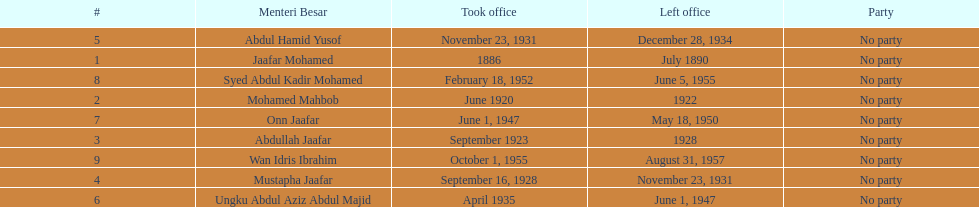Who were all of the menteri besars? Jaafar Mohamed, Mohamed Mahbob, Abdullah Jaafar, Mustapha Jaafar, Abdul Hamid Yusof, Ungku Abdul Aziz Abdul Majid, Onn Jaafar, Syed Abdul Kadir Mohamed, Wan Idris Ibrahim. When did they take office? 1886, June 1920, September 1923, September 16, 1928, November 23, 1931, April 1935, June 1, 1947, February 18, 1952, October 1, 1955. And when did they leave? July 1890, 1922, 1928, November 23, 1931, December 28, 1934, June 1, 1947, May 18, 1950, June 5, 1955, August 31, 1957. Now, who was in office for less than four years? Mohamed Mahbob. 